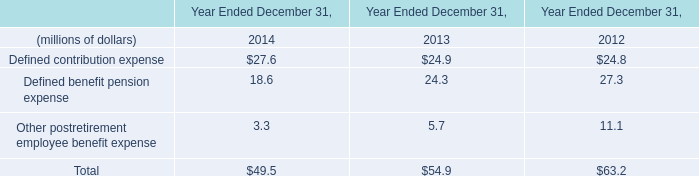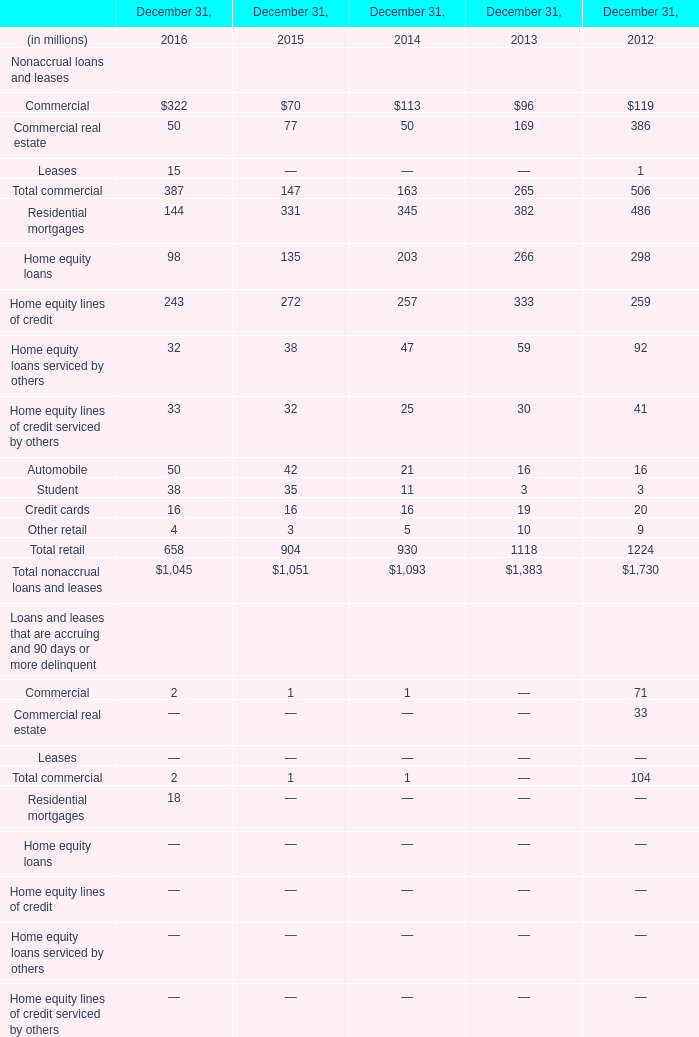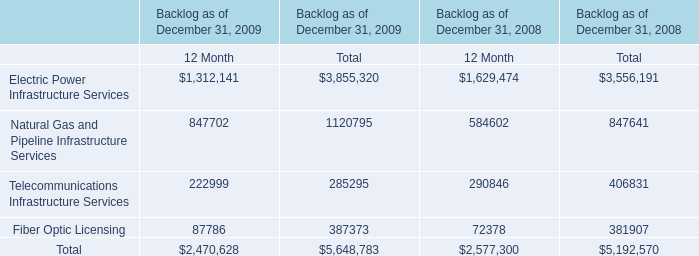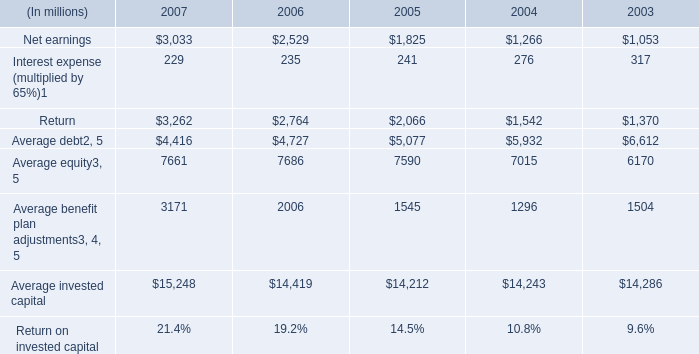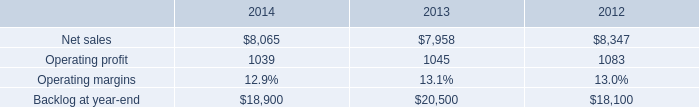What's the sum of the elements in Table 0 in the years where Troubled debt restructurings in Table 1 is greater than 910? (in million) 
Computations: ((27.6 + 18.6) + 3.3)
Answer: 49.5. 